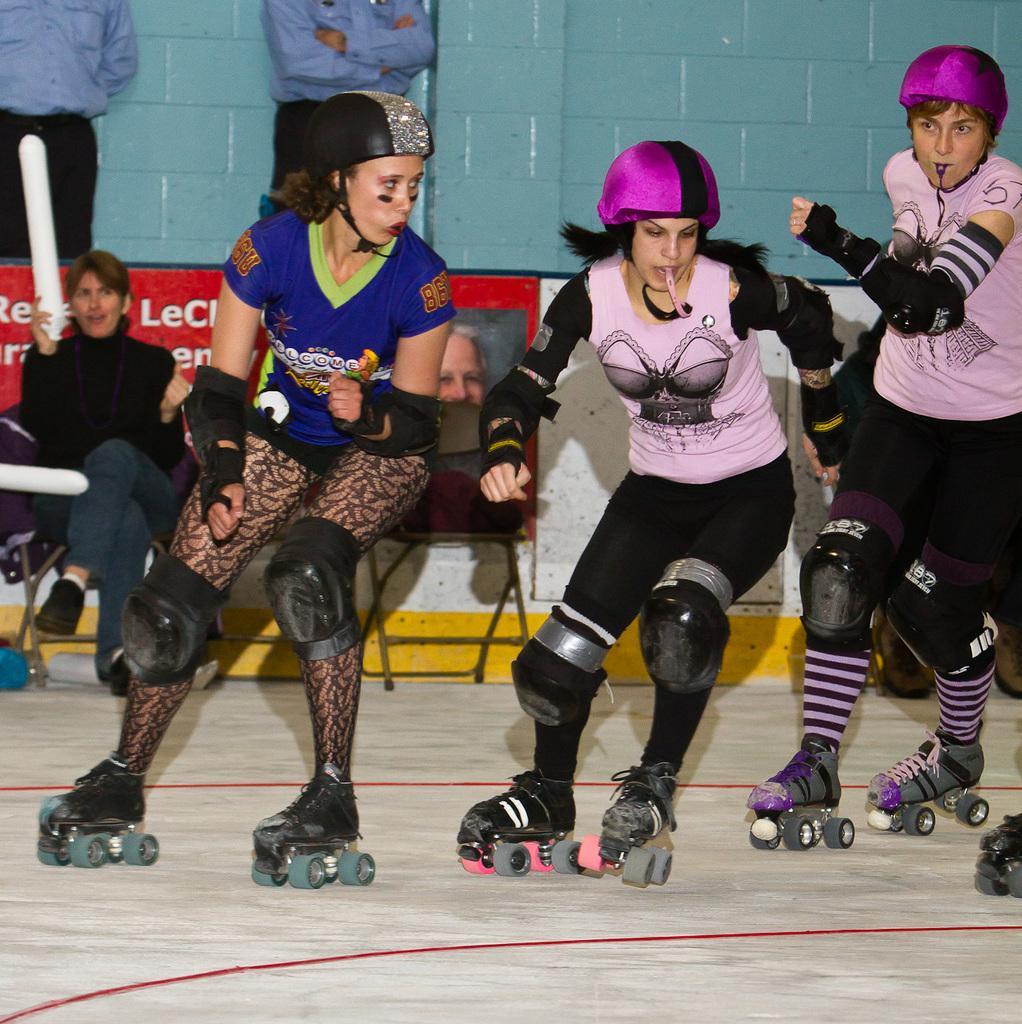Describe this image in one or two sentences. In the background we can see the wall, chairs, objects and people. We can see a person sitting on a chair and holding an object. In this picture we can see people wearing helmets and skating shoes. They are skating on the floor. 